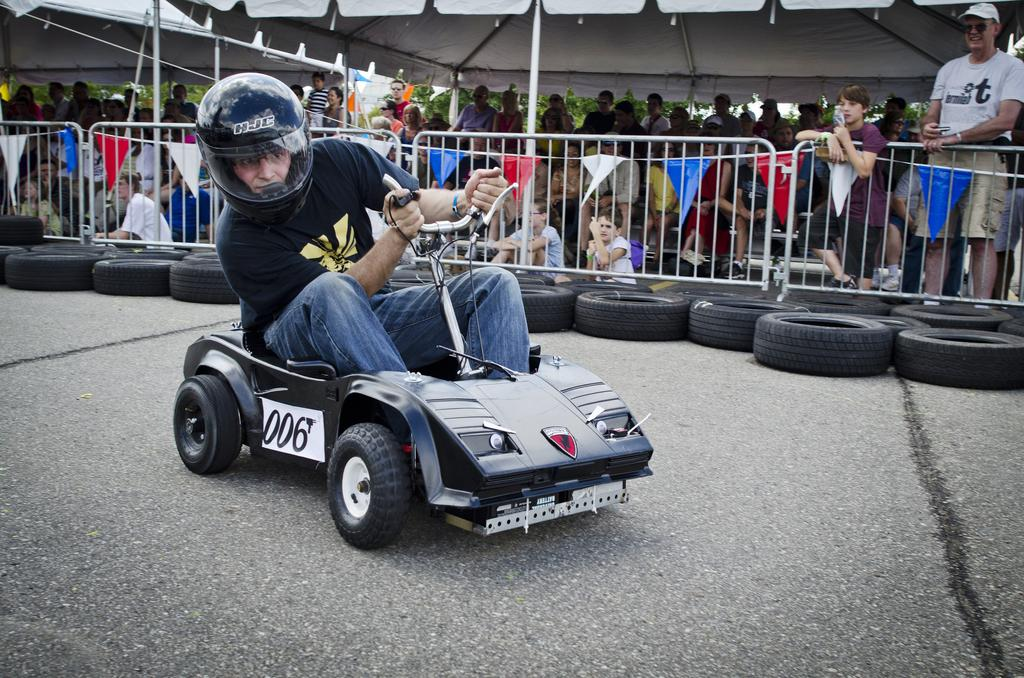What is the man in the image wearing? The man is wearing a helmet. What is the man doing in the image? The man is riding a vehicle. Where is the vehicle located in the image? The vehicle is on the road. What part of the vehicle is visible in the image? There are tyres visible in the image. What is present in the background of the image? There are trees in the background of the image. What is present in the foreground of the image? There is a group of people standing. What is present near the road in the image? There is a fence in the image. What is present near the fence in the image? There are flags in the image. What is present near the flags in the image? There are tents in the image. What type of grape is growing on the helmet of the man in the image? There is no grape growing on the helmet of the man in the image. 